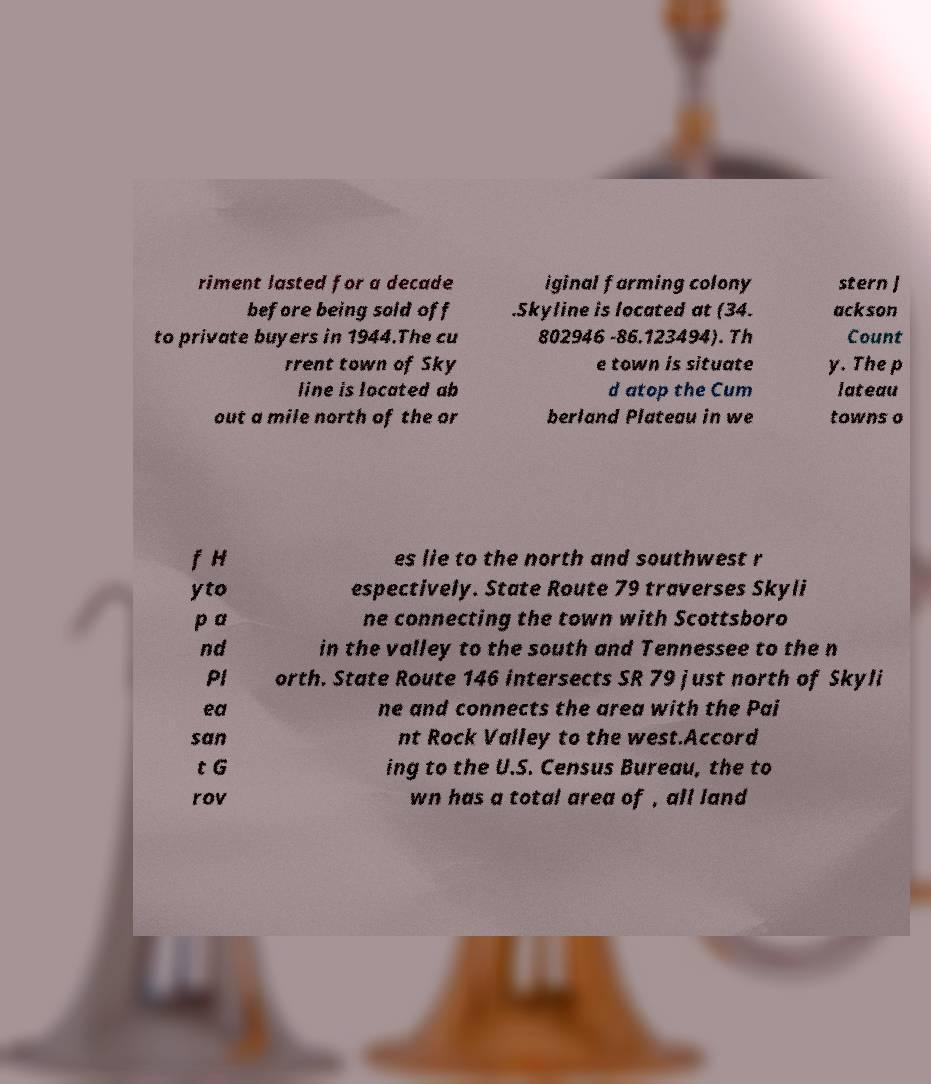Could you extract and type out the text from this image? riment lasted for a decade before being sold off to private buyers in 1944.The cu rrent town of Sky line is located ab out a mile north of the or iginal farming colony .Skyline is located at (34. 802946 -86.123494). Th e town is situate d atop the Cum berland Plateau in we stern J ackson Count y. The p lateau towns o f H yto p a nd Pl ea san t G rov es lie to the north and southwest r espectively. State Route 79 traverses Skyli ne connecting the town with Scottsboro in the valley to the south and Tennessee to the n orth. State Route 146 intersects SR 79 just north of Skyli ne and connects the area with the Pai nt Rock Valley to the west.Accord ing to the U.S. Census Bureau, the to wn has a total area of , all land 